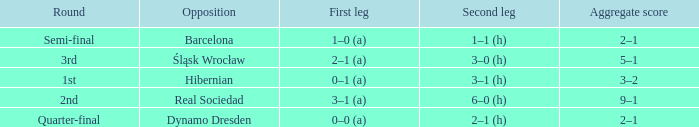Who were the opposition in the quarter-final? Dynamo Dresden. 